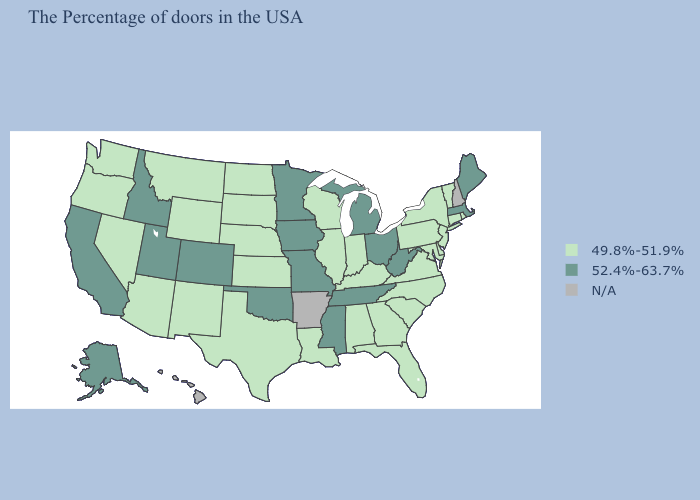What is the lowest value in the Northeast?
Short answer required. 49.8%-51.9%. Which states hav the highest value in the West?
Quick response, please. Colorado, Utah, Idaho, California, Alaska. Does Illinois have the lowest value in the MidWest?
Concise answer only. Yes. What is the lowest value in states that border South Carolina?
Concise answer only. 49.8%-51.9%. Which states have the lowest value in the USA?
Write a very short answer. Rhode Island, Vermont, Connecticut, New York, New Jersey, Delaware, Maryland, Pennsylvania, Virginia, North Carolina, South Carolina, Florida, Georgia, Kentucky, Indiana, Alabama, Wisconsin, Illinois, Louisiana, Kansas, Nebraska, Texas, South Dakota, North Dakota, Wyoming, New Mexico, Montana, Arizona, Nevada, Washington, Oregon. What is the highest value in the USA?
Be succinct. 52.4%-63.7%. What is the value of Louisiana?
Concise answer only. 49.8%-51.9%. What is the value of Ohio?
Answer briefly. 52.4%-63.7%. Among the states that border Colorado , does Utah have the highest value?
Be succinct. Yes. Which states have the highest value in the USA?
Quick response, please. Maine, Massachusetts, West Virginia, Ohio, Michigan, Tennessee, Mississippi, Missouri, Minnesota, Iowa, Oklahoma, Colorado, Utah, Idaho, California, Alaska. What is the value of Hawaii?
Keep it brief. N/A. What is the value of Oklahoma?
Concise answer only. 52.4%-63.7%. What is the highest value in the West ?
Answer briefly. 52.4%-63.7%. 